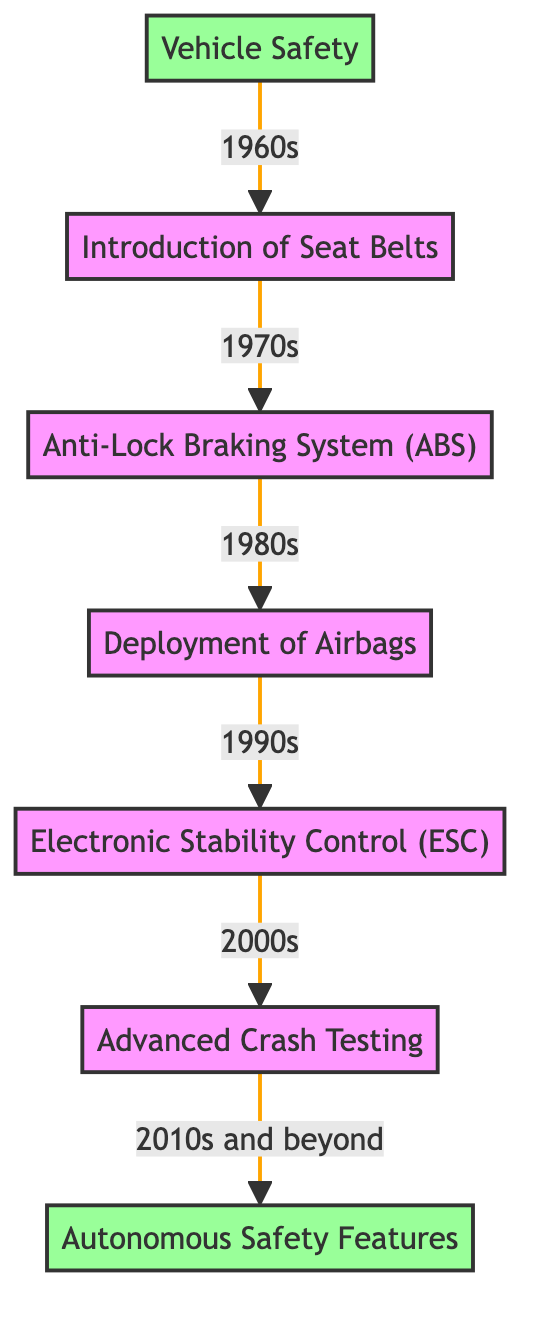What is the first safety feature introduced in General Motors vehicles? The diagram indicates that the first safety feature introduced is "Introduction of Seat Belts," which is linked to "Vehicle Safety" and labeled with the 1960s.
Answer: Introduction of Seat Belts How many nodes are in the diagram? Counting the nodes from the diagram, there are a total of 7 nodes, which include "Vehicle Safety," "Introduction of Seat Belts," "Anti-Lock Braking System (ABS)," "Deployment of Airbags," "Electronic Stability Control (ESC)," "Advanced Crash Testing," and "Autonomous Safety Features."
Answer: 7 Which decade saw the introduction of Anti-Lock Braking System (ABS)? According to the diagram's edges, "Anti-Lock Braking System (ABS)" is linked from "Introduction of Seat Belts" with a label indicating the 1970s.
Answer: 1970s What is the last safety feature in the evolution sequence? The last node in the directed graph, following the progression of features, is "Autonomous Safety Features," which is the final link following "Advanced Crash Testing."
Answer: Autonomous Safety Features What relationship exists between Airbags and Stability Control? The edge from "Deployment of Airbags" to "Electronic Stability Control (ESC)" is labeled with the 1990s, showing a direct relationship where Airbags led into the development of Stability Control.
Answer: 1990s What safety feature was developed after Advanced Crash Testing? The directed graph shows that "Advanced Crash Testing" leads to "Autonomous Safety Features," indicating that these features were developed subsequently.
Answer: Autonomous Safety Features How many edges are present in the graph? By counting the connections (edges) between nodes in the diagram, there are 6 edges that represent the evolution of safety features from "Vehicle Safety" to "Autonomous Safety Features."
Answer: 6 Which safety feature was introduced in the 1980s? The diagram clearly shows that "Deployment of Airbags" is the feature introduced in the 1980s, as it follows directly after "Anti-Lock Braking System (ABS)."
Answer: Deployment of Airbags 